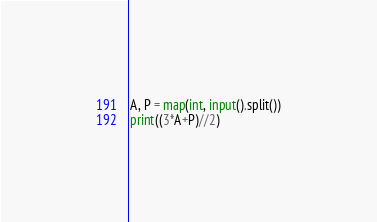Convert code to text. <code><loc_0><loc_0><loc_500><loc_500><_Python_>A, P = map(int, input().split())
print((3*A+P)//2)</code> 